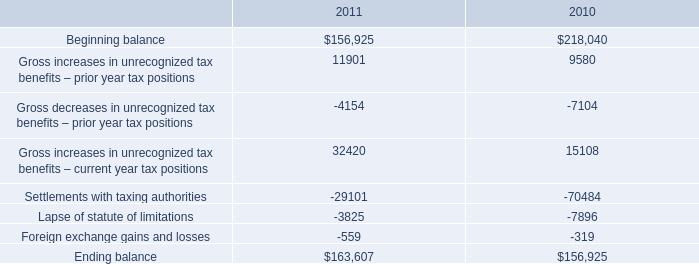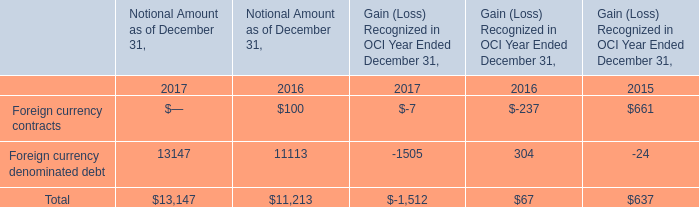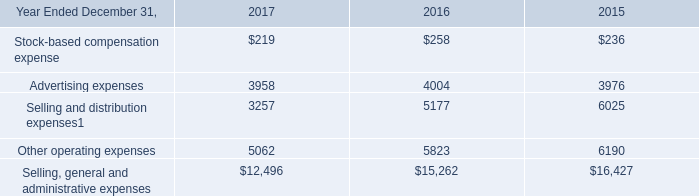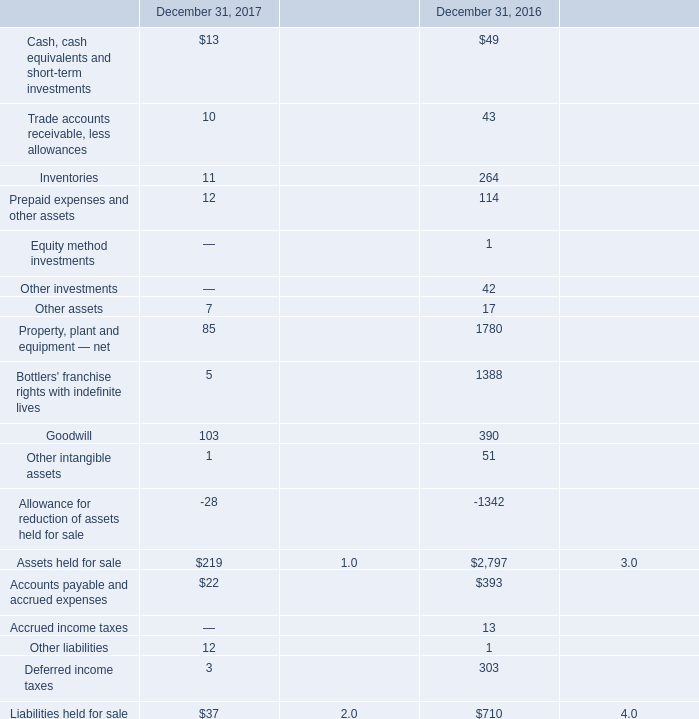What is the average amount of Property, plant and equipment — net of December 31, 2016, and Selling, general and administrative expenses of 2016 ? 
Computations: ((1780.0 + 15262.0) / 2)
Answer: 8521.0. 